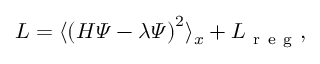Convert formula to latex. <formula><loc_0><loc_0><loc_500><loc_500>L = \langle \left ( H \varPsi - \lambda \varPsi \right ) ^ { 2 } \rangle _ { x } + L _ { r e g } ,</formula> 